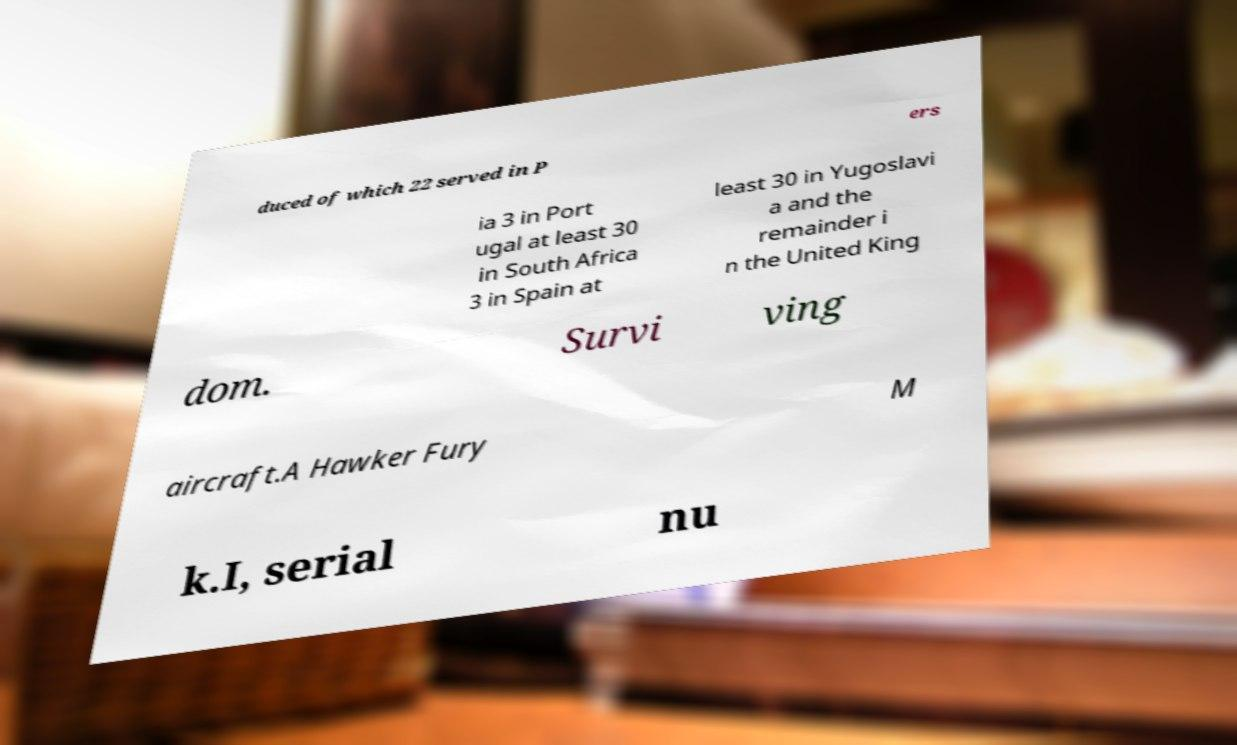Please read and relay the text visible in this image. What does it say? duced of which 22 served in P ers ia 3 in Port ugal at least 30 in South Africa 3 in Spain at least 30 in Yugoslavi a and the remainder i n the United King dom. Survi ving aircraft.A Hawker Fury M k.I, serial nu 